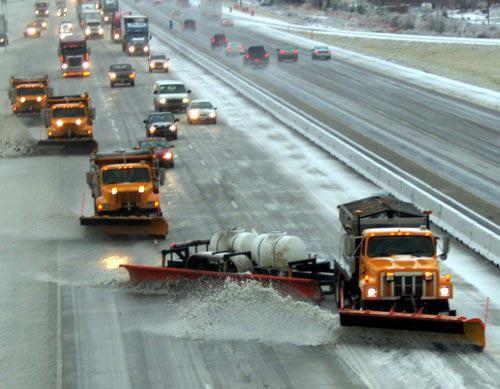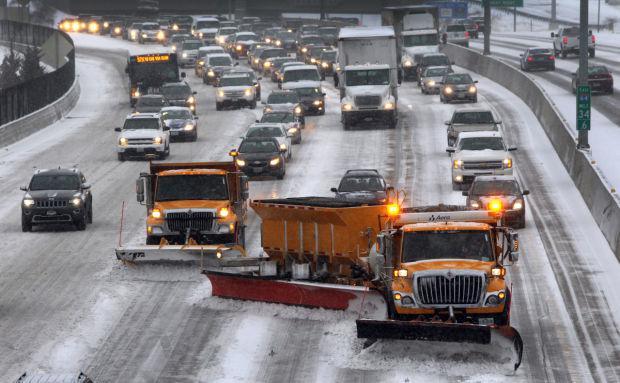The first image is the image on the left, the second image is the image on the right. For the images shown, is this caption "Both images feature in the foreground a tow plow pulled by a truck with a bright yellow cab." true? Answer yes or no. Yes. The first image is the image on the left, the second image is the image on the right. Evaluate the accuracy of this statement regarding the images: "There are more than three vehicles in the right image.". Is it true? Answer yes or no. Yes. 